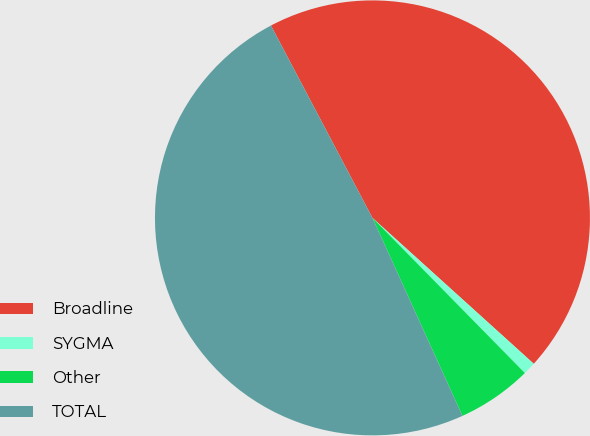Convert chart to OTSL. <chart><loc_0><loc_0><loc_500><loc_500><pie_chart><fcel>Broadline<fcel>SYGMA<fcel>Other<fcel>TOTAL<nl><fcel>44.43%<fcel>0.94%<fcel>5.57%<fcel>49.06%<nl></chart> 